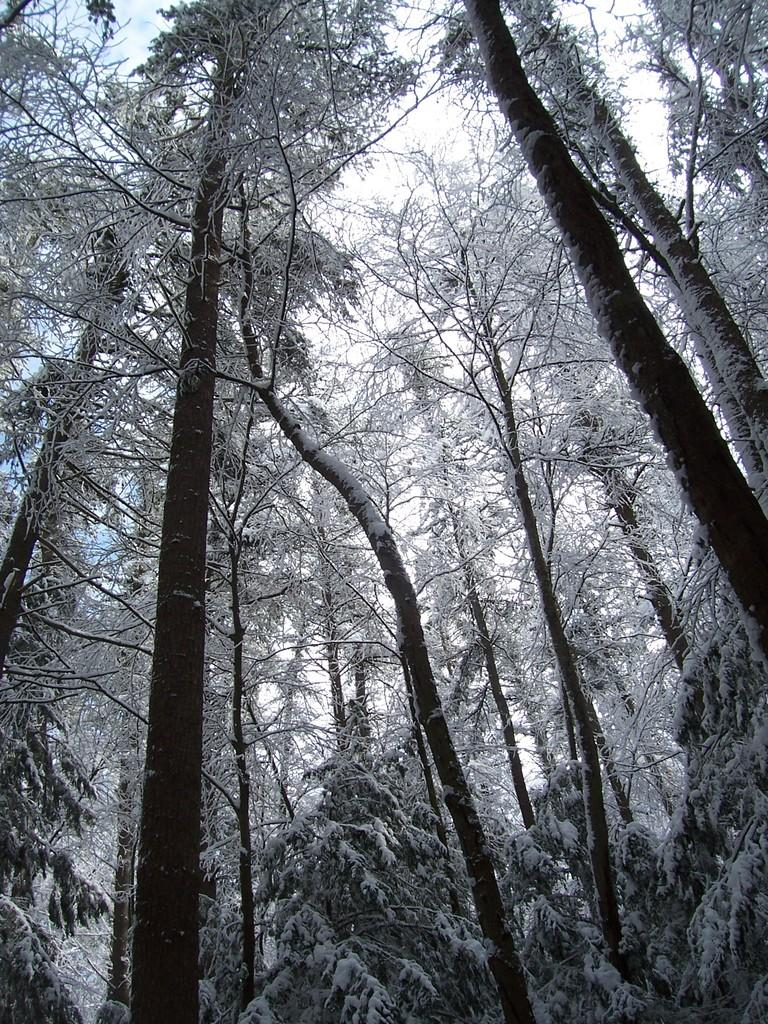What type of vegetation can be seen in the image? There are trees in the image. What is covering the trees in the image? The trees are covered with snow. What can be seen in the background of the image? The sky is visible in the background of the image. Can you see a rose growing on one of the trees in the image? There is no rose visible on the trees in the image; they are covered with snow. 